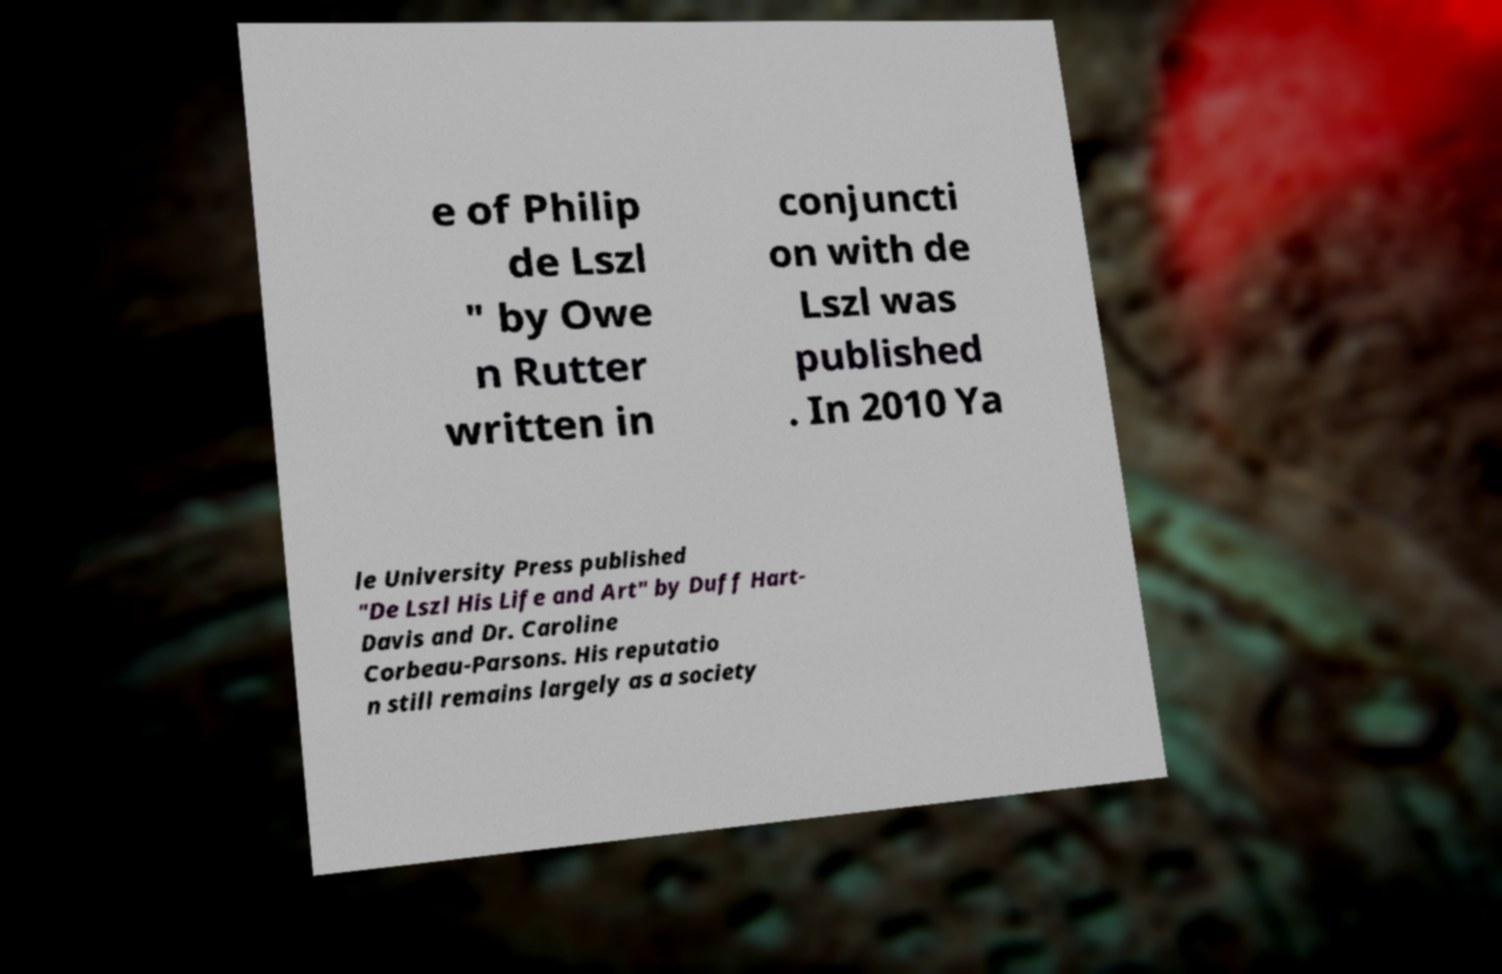Please identify and transcribe the text found in this image. e of Philip de Lszl " by Owe n Rutter written in conjuncti on with de Lszl was published . In 2010 Ya le University Press published "De Lszl His Life and Art" by Duff Hart- Davis and Dr. Caroline Corbeau-Parsons. His reputatio n still remains largely as a society 